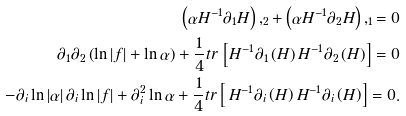<formula> <loc_0><loc_0><loc_500><loc_500>\left ( \alpha H ^ { - 1 } \partial _ { 1 } H \right ) , _ { 2 } + \left ( \alpha H ^ { - 1 } \partial _ { 2 } H \right ) , _ { 1 } = 0 \\ \partial _ { 1 } \partial _ { 2 } \left ( \ln \left | f \right | + \ln \alpha \right ) + \frac { 1 } { 4 } t r \, \left [ H ^ { - 1 } \partial _ { 1 } \left ( H \right ) H ^ { - 1 } \partial _ { 2 } \left ( H \right ) \right ] = 0 \\ - \partial _ { i } \ln \left | \alpha \right | \partial _ { i } \ln \left | f \right | + \partial _ { i } ^ { 2 } \ln \alpha + \frac { 1 } { 4 } t r \left [ \, H ^ { - 1 } \partial _ { i } \left ( H \right ) H ^ { - 1 } \partial _ { i } \left ( H \right ) \right ] = 0 .</formula> 